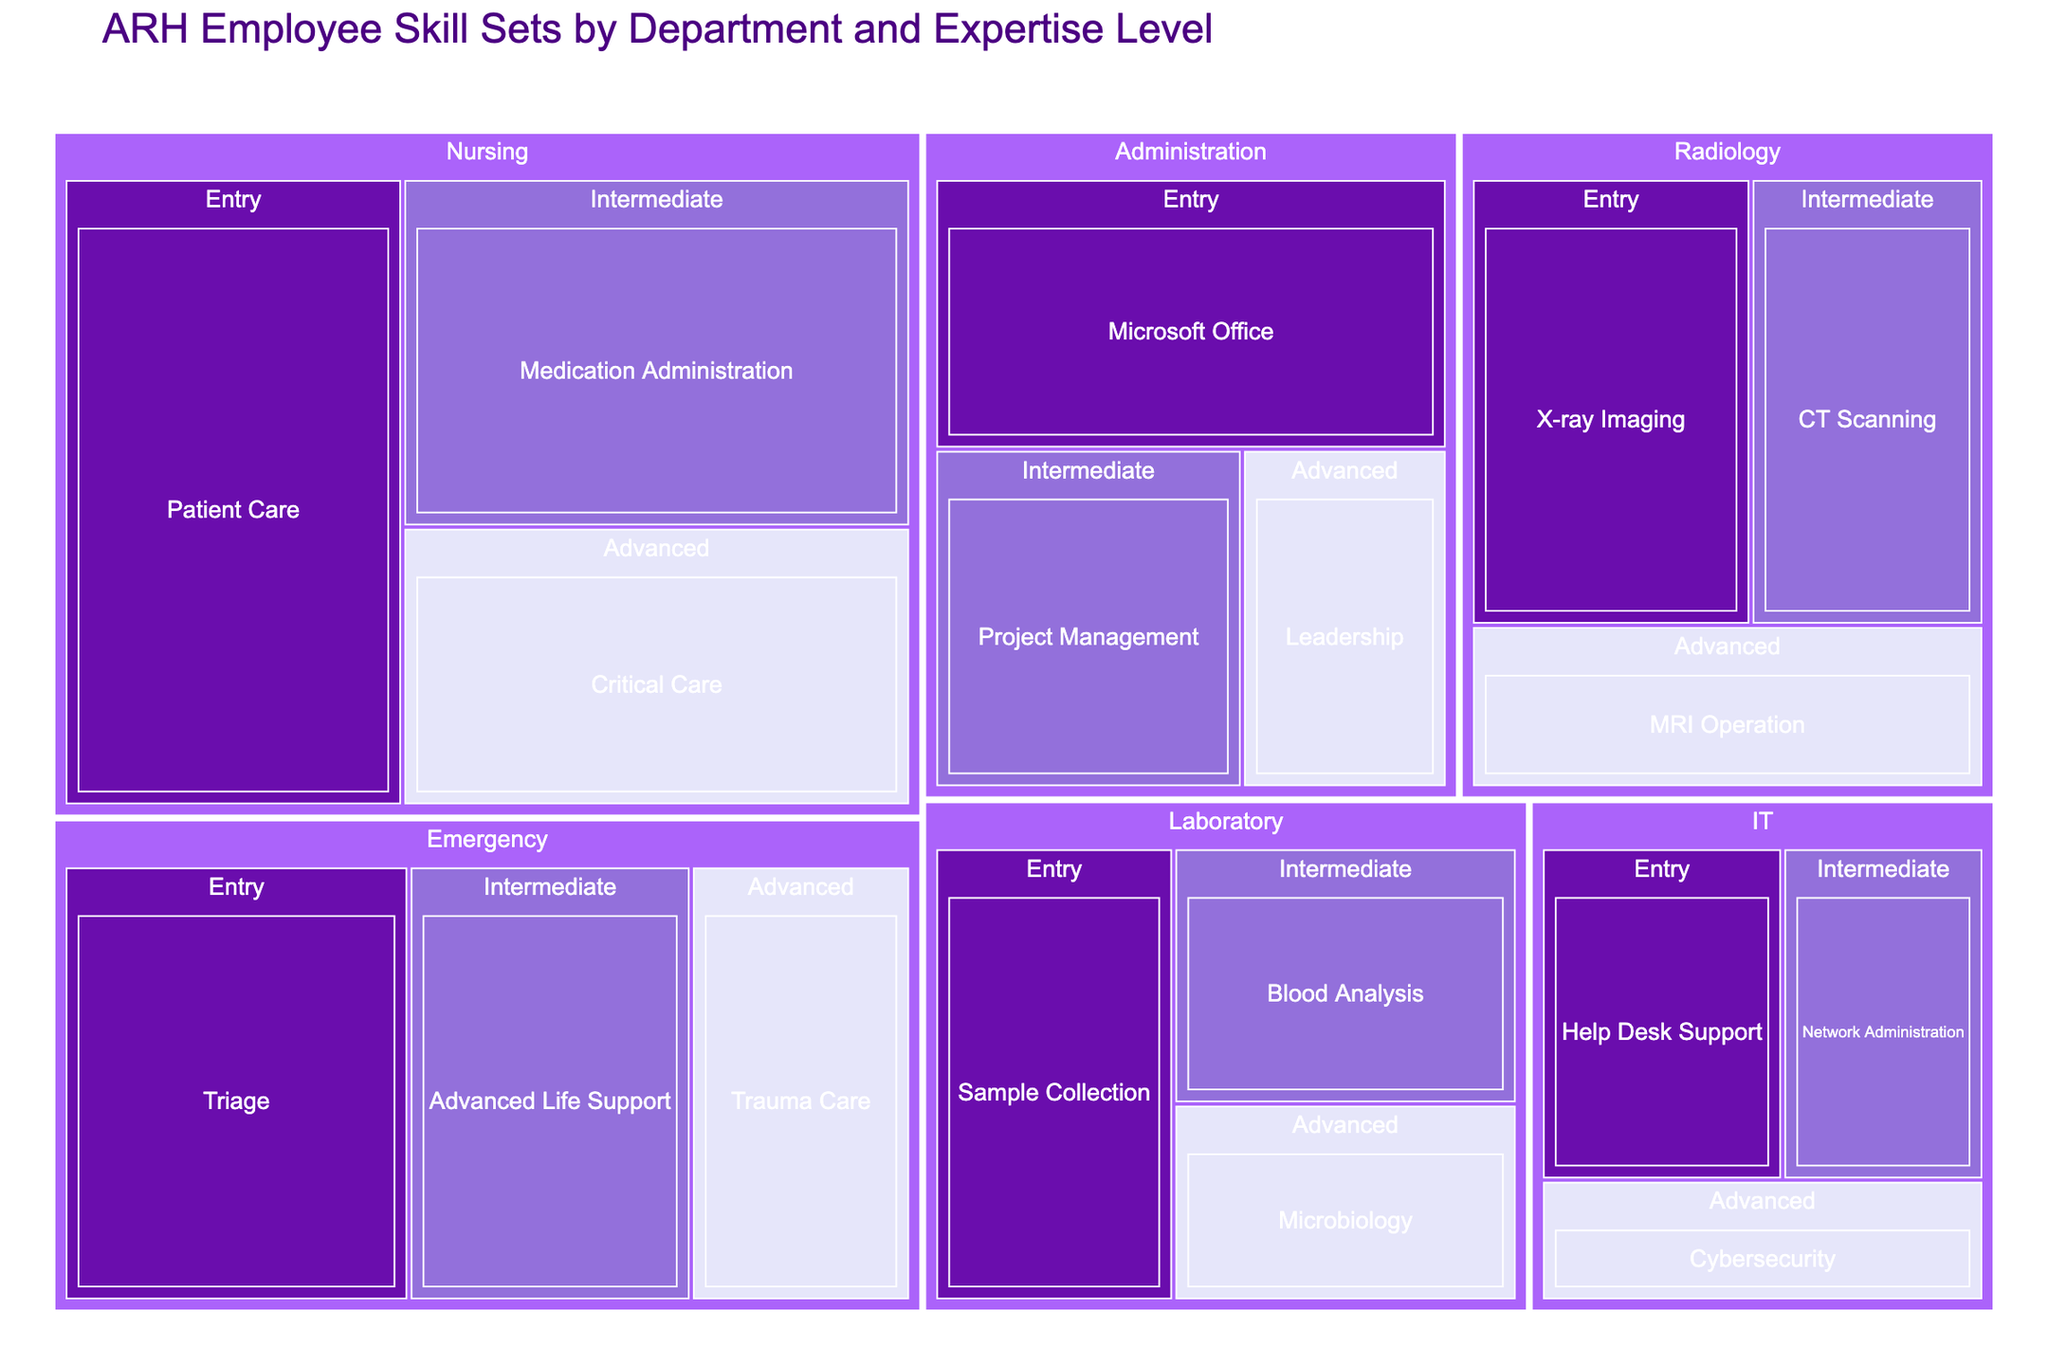What's the title of the figure? The title is typically displayed at the top of the figure.
Answer: ARH Employee Skill Sets by Department and Expertise Level How many departments are represented in the treemap? Count the distinct department names shown in the figure.
Answer: 6 Which department has the most entry-level skills? Look for the department with the largest area under the 'Entry' expertise category.
Answer: Nursing What is the value for the 'Advanced' level skill in the IT department? Navigate to the IT department, then find the section labeled 'Advanced' and check the value.
Answer: 8 Compare the 'Intermediate' skill values between the Radiology and Emergency departments. Which one is higher? Locate the 'Intermediate' sections for both Radiology and Emergency departments and compare their values.
Answer: Emergency What are the skill names under the 'Administration' department? Identify and list all the skill names grouped under the Administration department.
Answer: Microsoft Office, Project Management, Leadership What is the total value of skills for the 'Laboratory' department? Sum the values for all skill levels (Entry, Intermediate, Advanced) under the Laboratory department. 16 (Entry) + 13 (Intermediate) + 10 (Advanced) = 39
Answer: 39 In terms of skill value, is 'Medication Administration' for Nursing greater than 'Critical Care' for Nursing? Compare the values for 'Medication Administration' and 'Critical Care' under the Nursing department.
Answer: Yes Which expertise level (Entry, Intermediate, Advanced) has the highest total value across all departments? Sum the values for all skills under each expertise level and see which is highest. Entry: 20 + 30 + 12 + 18 + 22 + 16 = 118; Intermediate: 15 + 25 + 10 + 15 + 18 + 13 = 96; Advanced: 10 + 20 + 8 + 12 + 14 + 10 = 74
Answer: Entry What's the combined value of 'Advanced Life Support' and 'Trauma Care' in the Emergency department? Add the values of 'Advanced Life Support' and 'Trauma Care' under the Emergency department. 18 (Advanced Life Support) + 14 (Trauma Care) = 32
Answer: 32 